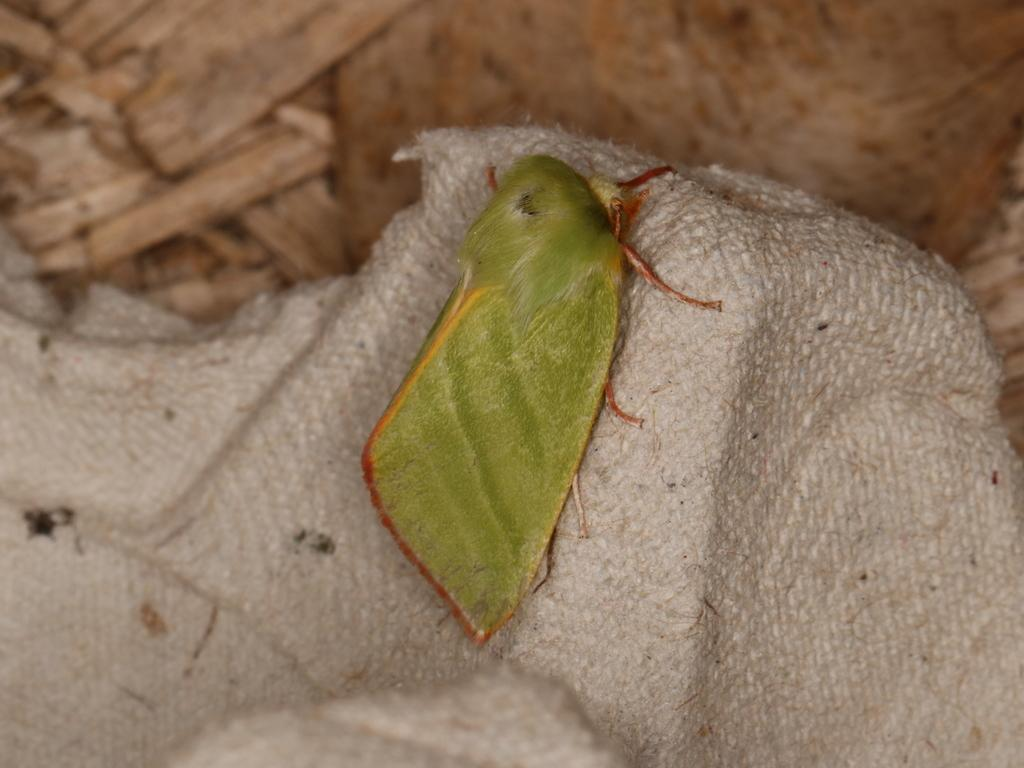What type of creature is present in the image? There is an insect in the image. How is the background of the image depicted? The background of the insect is blurred. How many cars are visible in the image? There are no cars present in the image; it features an insect with a blurred background. Is there a basketball court visible in the image? There is no basketball court present in the image; it features an insect with a blurred background. 